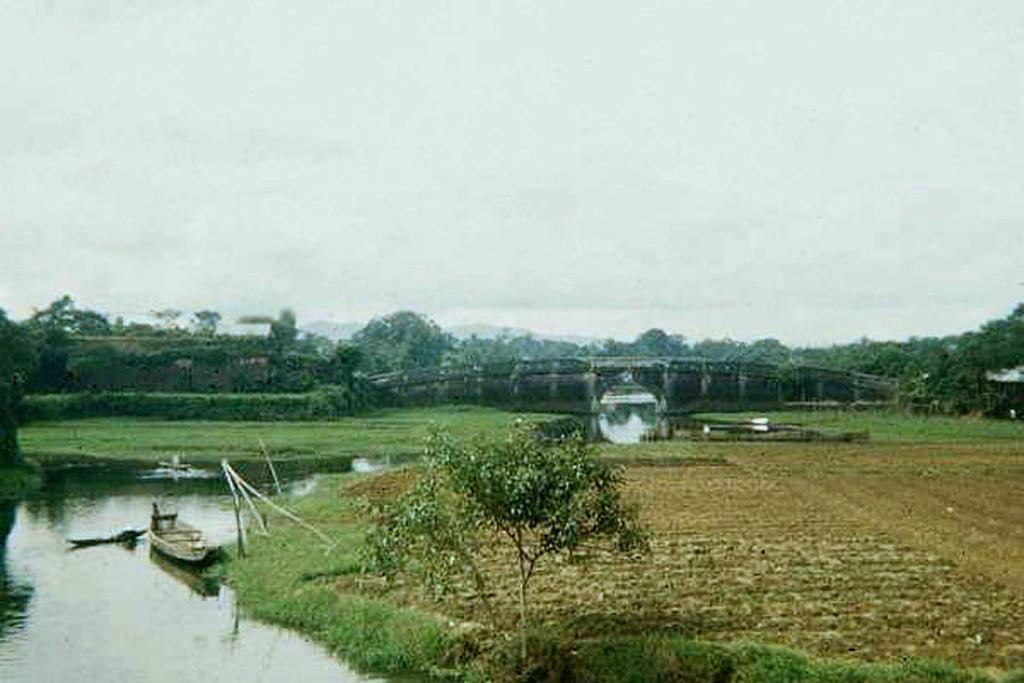How would you summarize this image in a sentence or two? In this image, we can see some trees and grass. There is a bridge in the middle of the image. There is a boat in the bottom left of the image floating on the water. At the top of the image, we can see the sky. 